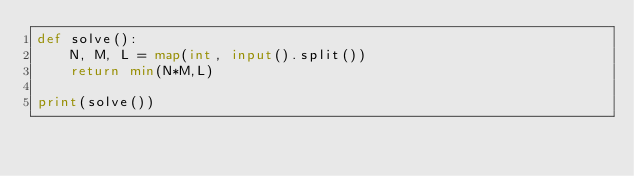<code> <loc_0><loc_0><loc_500><loc_500><_Python_>def solve():
    N, M, L = map(int, input().split())
    return min(N*M,L)

print(solve())</code> 